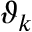<formula> <loc_0><loc_0><loc_500><loc_500>\vartheta _ { k }</formula> 